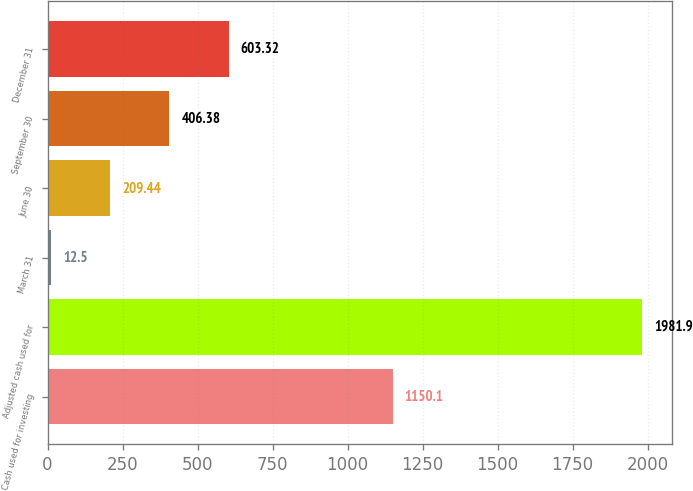Convert chart. <chart><loc_0><loc_0><loc_500><loc_500><bar_chart><fcel>Cash used for investing<fcel>Adjusted cash used for<fcel>March 31<fcel>June 30<fcel>September 30<fcel>December 31<nl><fcel>1150.1<fcel>1981.9<fcel>12.5<fcel>209.44<fcel>406.38<fcel>603.32<nl></chart> 